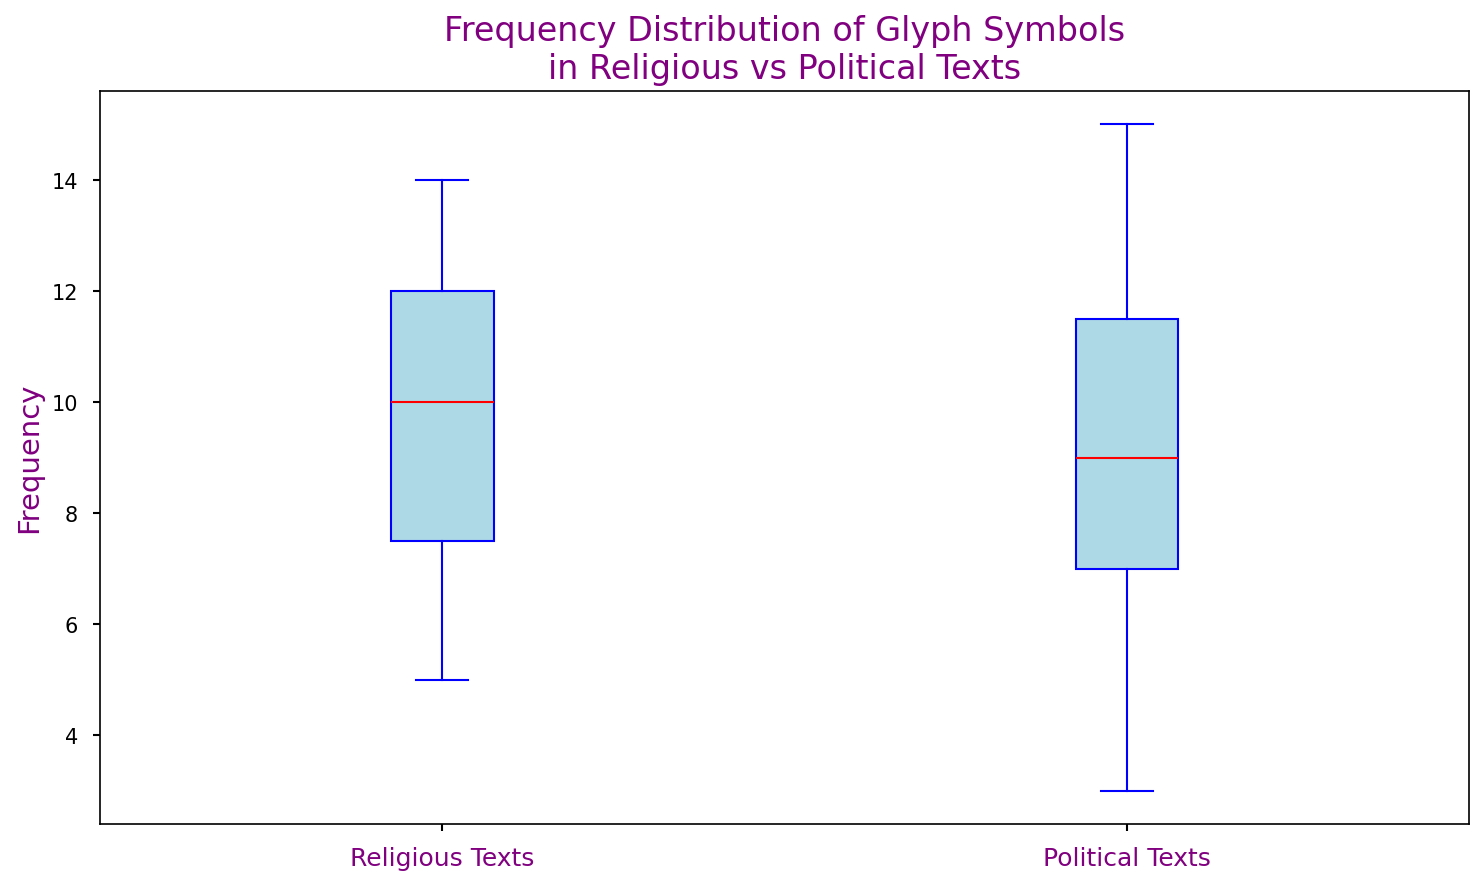What's the median frequency of glyph symbols in religious texts? To find the median, we first list the frequencies of religious glyph symbols: [12, 5, 9, 14, 8, 10, 7, 6, 11, 13, 10, 8, 12, 6, 14]. Sorting them gives [5, 6, 6, 7, 8, 8, 9, 10, 10, 11, 12, 12, 13, 14, 14], and the middle value (median) is 10
Answer: 10 Which type of text has a higher overall spread in frequency distribution of glyph symbols? The difference between the highest and lowest values (range) indicates the spread. For religious texts: highest (14) - lowest (5) = 9. For political texts: highest (15) - lowest (3) = 12. The political texts have a higher overall spread.
Answer: Political texts What is the median frequency of glyph symbols in political texts? For the political texts, the frequencies are [15, 7, 8, 10, 5, 12, 6, 3, 9, 11, 13, 7, 11, 9, 12]. Sorting these gives [3, 5, 6, 7, 7, 8, 9, 9, 10, 11, 11, 12, 12, 13, 15], and the middle value (median) is 9
Answer: 9 How do the median frequencies compare between religious and political texts? The median frequency for religious texts is 10, and for political texts, it is 9. Comparing these, the median frequency is higher in religious texts.
Answer: Religious texts are higher Which type of text has more outliers in the frequency distribution? Outliers can be identified with dots outside the whiskers. By counting the outliers in the visual representation, it will be evident which type has more outliers.
Answer: Need visual What is the interquartile range (IQR) for frequencies of political texts? To calculate the IQR, identify Q1 (25th percentile) and Q3 (75th percentile). Sorted frequencies for political texts: [3, 5, 6, 7, 7, 8, 9, 9, 10, 11, 11, 12, 12, 13, 15]. Q1 is the 4th value (7) and Q3 is the 12th value (12). So, IQR = Q3 - Q1 = 12 - 7 = 5
Answer: 5 Is there a visual difference in the color boxes for religious and political texts? Both box plots utilize distinct shades. Religious text boxplots should show as light blue, and similar for political texts, staying consistent with unique color settings in the plot code.
Answer: Yes Which category's box is located higher in the plot? The boxplot for religious texts is located higher on the y-axis compared to the political texts, indicating higher data points overall.
Answer: Religious texts 